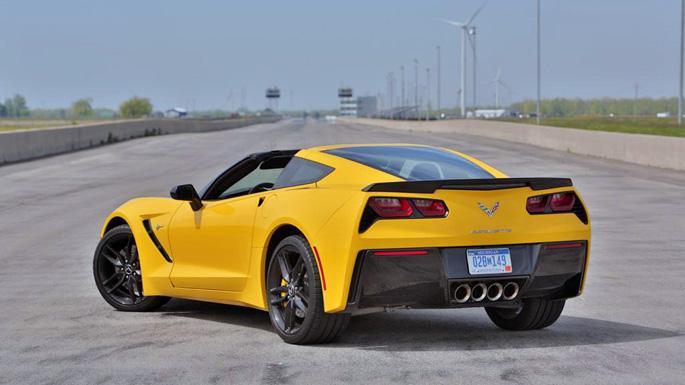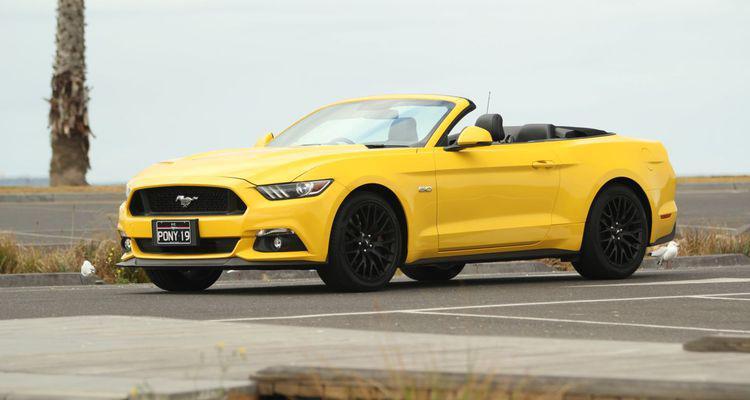The first image is the image on the left, the second image is the image on the right. Examine the images to the left and right. Is the description "One image shows a leftward-angled yellow convertible without a hood stripe, and the other features a right-turned convertible with black stripes on its hood." accurate? Answer yes or no. No. The first image is the image on the left, the second image is the image on the right. For the images shown, is this caption "The right image contains one yellow car that is facing towards the right." true? Answer yes or no. No. 